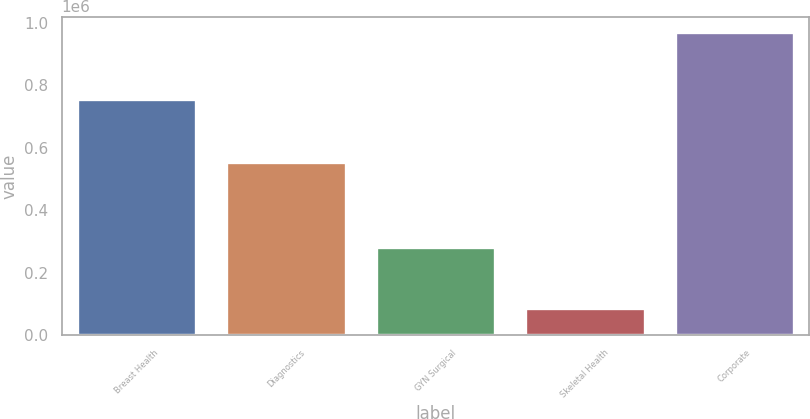Convert chart to OTSL. <chart><loc_0><loc_0><loc_500><loc_500><bar_chart><fcel>Breast Health<fcel>Diagnostics<fcel>GYN Surgical<fcel>Skeletal Health<fcel>Corporate<nl><fcel>755542<fcel>552501<fcel>283142<fcel>88367<fcel>970579<nl></chart> 